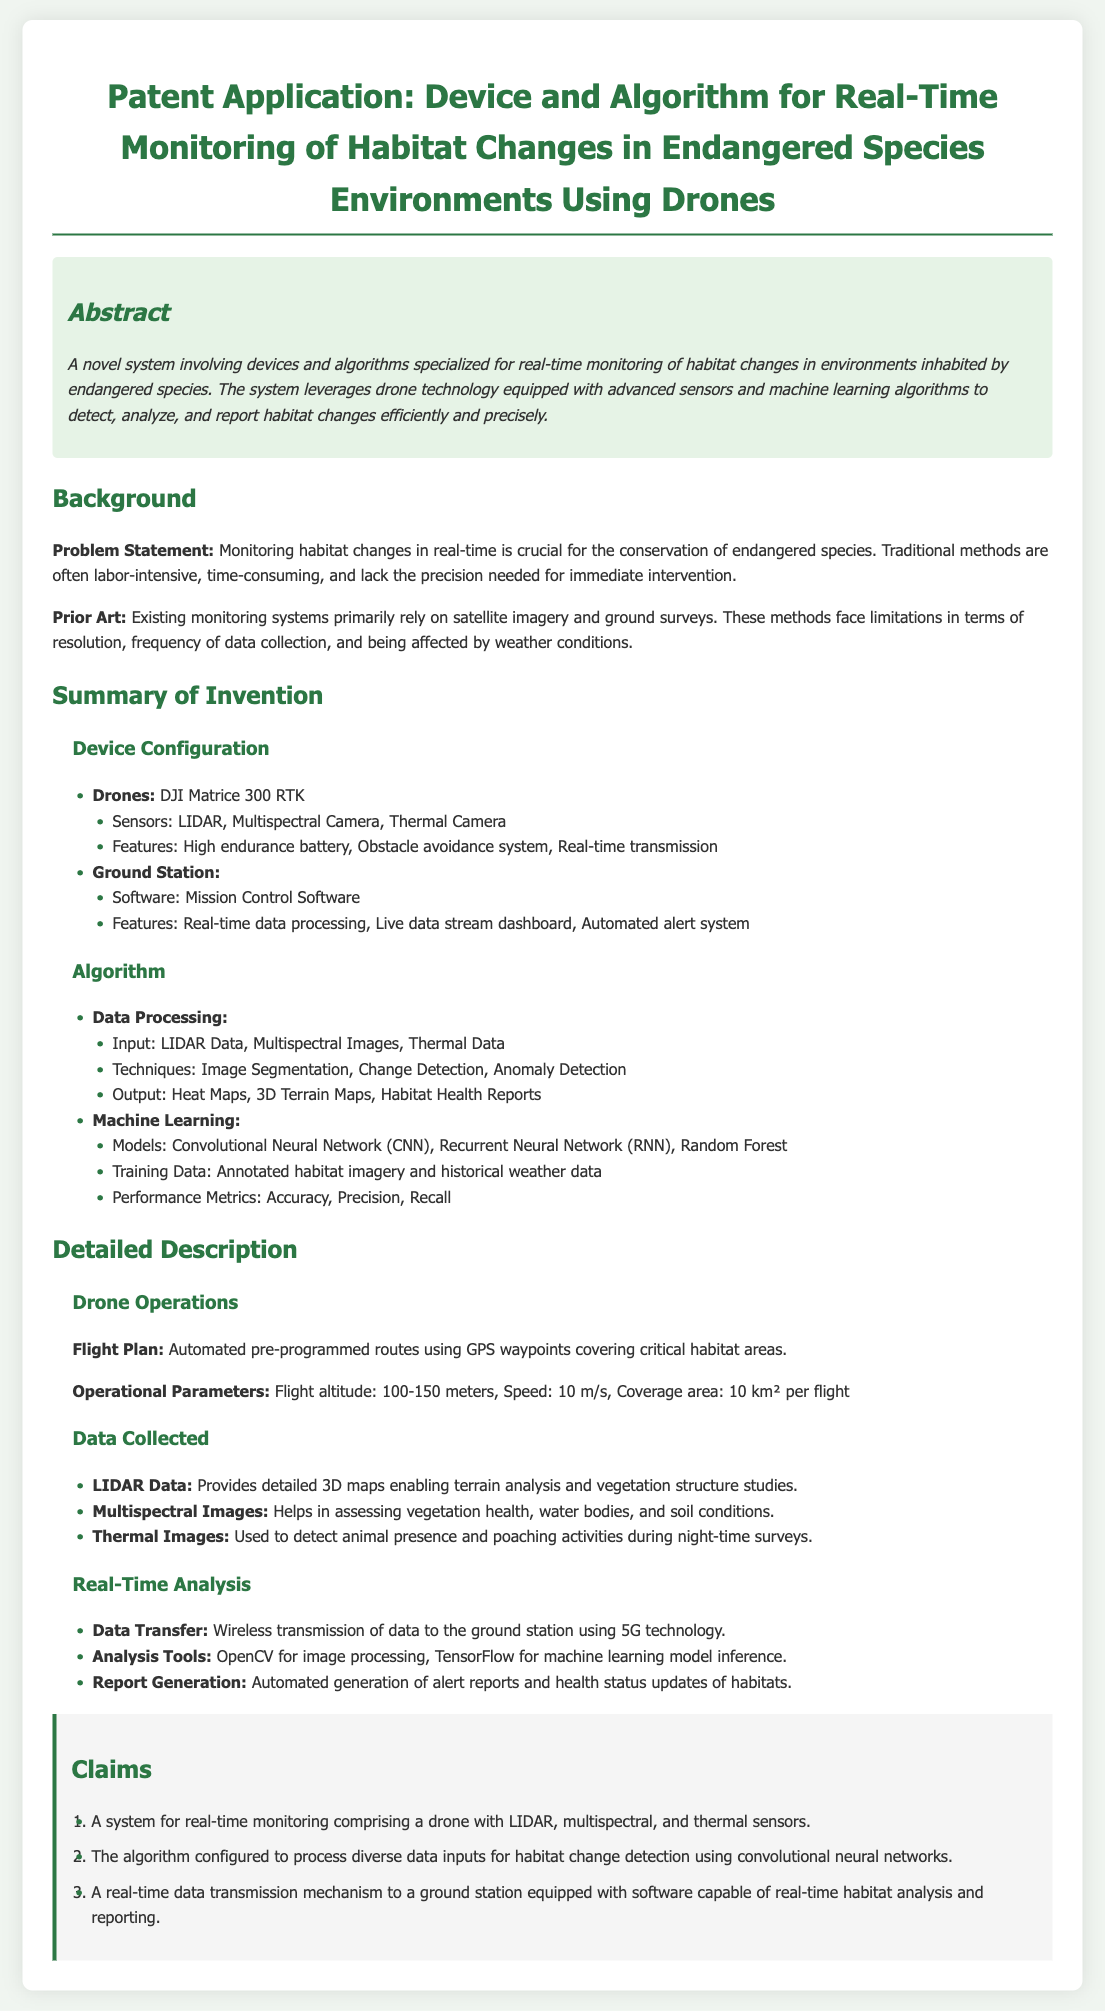What drone model is used in the system? The document specifies that the drone model used is DJI Matrice 300 RTK.
Answer: DJI Matrice 300 RTK What is the primary purpose of the proposed system? The system is designed for real-time monitoring of habitat changes in environments inhabited by endangered species.
Answer: Real-time monitoring of habitat changes What types of sensors are equipped on the drone? The document lists LIDAR, Multispectral Camera, and Thermal Camera as the types of sensors.
Answer: LIDAR, Multispectral Camera, Thermal Camera What is the flight altitude for drone operations? The operational parameters indicate a flight altitude range of 100-150 meters.
Answer: 100-150 meters Which machine learning model is mentioned in the document? The claims section references the Convolutional Neural Network (CNN) as a machine learning model.
Answer: Convolutional Neural Network (CNN) How much area does the drone cover per flight? The document states that the coverage area planned for each flight is 10 km².
Answer: 10 km² What technology is used for real-time data transmission? The system employs 5G technology for the wireless transmission of data to the ground station.
Answer: 5G technology What does the LIDAR data provide according to the document? The document explains that LIDAR data provides detailed 3D maps enabling terrain analysis and vegetation structure studies.
Answer: Detailed 3D maps What feature does the ground station software include? The ground station software includes a live data stream dashboard as a key feature.
Answer: Live data stream dashboard 